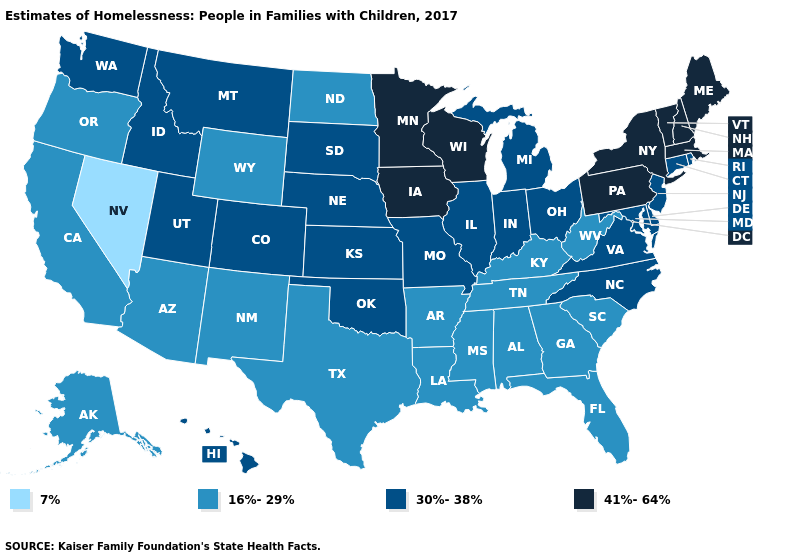Name the states that have a value in the range 16%-29%?
Keep it brief. Alabama, Alaska, Arizona, Arkansas, California, Florida, Georgia, Kentucky, Louisiana, Mississippi, New Mexico, North Dakota, Oregon, South Carolina, Tennessee, Texas, West Virginia, Wyoming. How many symbols are there in the legend?
Give a very brief answer. 4. Name the states that have a value in the range 41%-64%?
Keep it brief. Iowa, Maine, Massachusetts, Minnesota, New Hampshire, New York, Pennsylvania, Vermont, Wisconsin. What is the lowest value in the USA?
Concise answer only. 7%. Name the states that have a value in the range 41%-64%?
Short answer required. Iowa, Maine, Massachusetts, Minnesota, New Hampshire, New York, Pennsylvania, Vermont, Wisconsin. Which states have the lowest value in the South?
Short answer required. Alabama, Arkansas, Florida, Georgia, Kentucky, Louisiana, Mississippi, South Carolina, Tennessee, Texas, West Virginia. Does the map have missing data?
Keep it brief. No. What is the value of New Jersey?
Give a very brief answer. 30%-38%. Does Michigan have a higher value than Vermont?
Be succinct. No. Among the states that border Illinois , does Indiana have the highest value?
Answer briefly. No. Name the states that have a value in the range 41%-64%?
Give a very brief answer. Iowa, Maine, Massachusetts, Minnesota, New Hampshire, New York, Pennsylvania, Vermont, Wisconsin. Among the states that border Rhode Island , which have the highest value?
Concise answer only. Massachusetts. What is the lowest value in the MidWest?
Answer briefly. 16%-29%. Which states have the highest value in the USA?
Write a very short answer. Iowa, Maine, Massachusetts, Minnesota, New Hampshire, New York, Pennsylvania, Vermont, Wisconsin. 